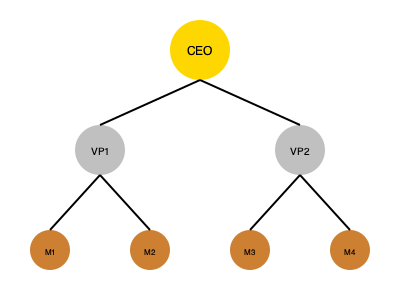Based on the hierarchical team structure shown, how many direct reports does each VP have, and what is the total number of employees at the manager level? To answer this question, we need to analyze the hierarchical structure depicted in the image:

1. The top circle represents the CEO.
2. There are two circles in the second row, labeled VP1 and VP2, representing two Vice Presidents.
3. The bottom row contains four circles labeled M1, M2, M3, and M4, representing managers.

Now, let's break down the reporting structure:

1. VP1 (left side):
   - Has two lines connecting to M1 and M2
   - Therefore, VP1 has 2 direct reports

2. VP2 (right side):
   - Has two lines connecting to M3 and M4
   - Therefore, VP2 has 2 direct reports

3. Total number of employees at the manager level:
   - There are four circles in the bottom row (M1, M2, M3, M4)
   - Therefore, there are 4 employees at the manager level

So, each VP has 2 direct reports, and there are 4 managers in total.
Answer: 2 direct reports per VP; 4 managers total 